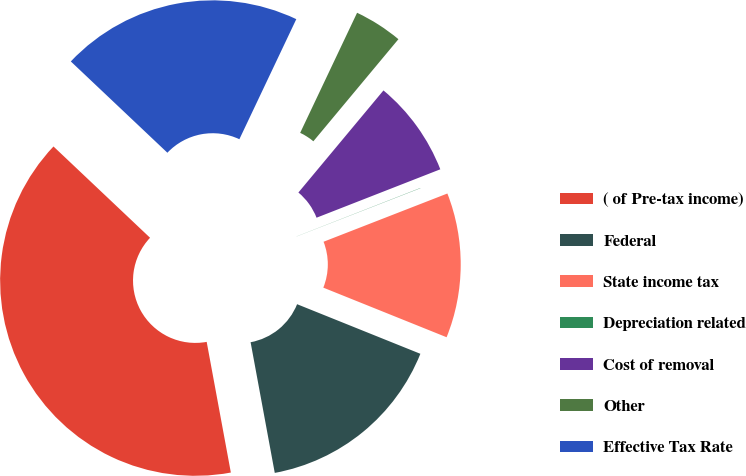<chart> <loc_0><loc_0><loc_500><loc_500><pie_chart><fcel>( of Pre-tax income)<fcel>Federal<fcel>State income tax<fcel>Depreciation related<fcel>Cost of removal<fcel>Other<fcel>Effective Tax Rate<nl><fcel>39.96%<fcel>16.0%<fcel>12.0%<fcel>0.02%<fcel>8.01%<fcel>4.01%<fcel>19.99%<nl></chart> 